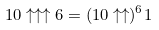<formula> <loc_0><loc_0><loc_500><loc_500>1 0 \uparrow \uparrow \uparrow 6 = ( 1 0 \uparrow \uparrow ) ^ { 6 } 1</formula> 